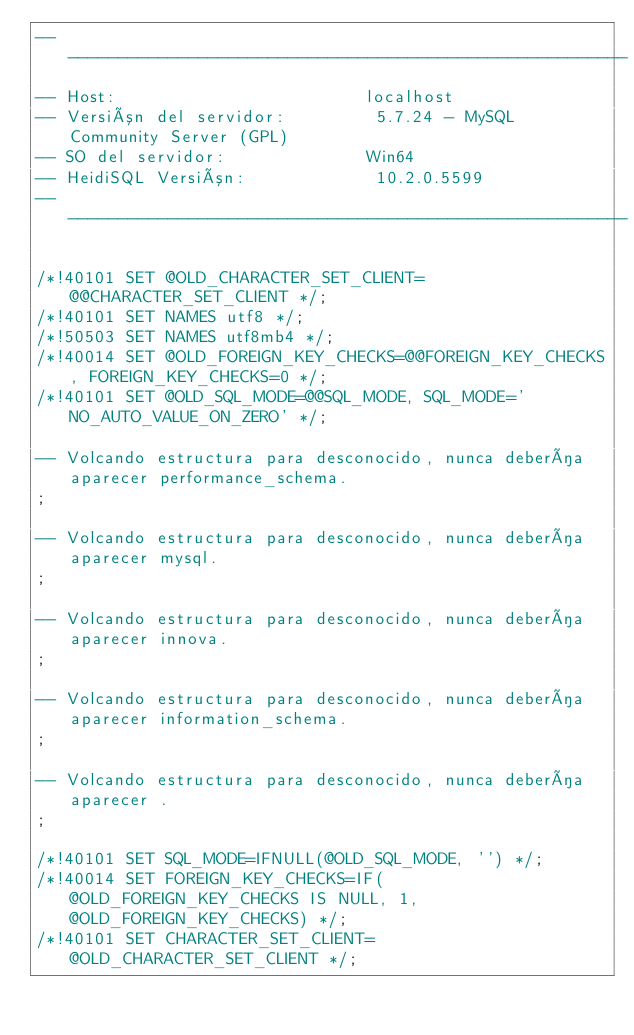Convert code to text. <code><loc_0><loc_0><loc_500><loc_500><_SQL_>-- --------------------------------------------------------
-- Host:                         localhost
-- Versión del servidor:         5.7.24 - MySQL Community Server (GPL)
-- SO del servidor:              Win64
-- HeidiSQL Versión:             10.2.0.5599
-- --------------------------------------------------------

/*!40101 SET @OLD_CHARACTER_SET_CLIENT=@@CHARACTER_SET_CLIENT */;
/*!40101 SET NAMES utf8 */;
/*!50503 SET NAMES utf8mb4 */;
/*!40014 SET @OLD_FOREIGN_KEY_CHECKS=@@FOREIGN_KEY_CHECKS, FOREIGN_KEY_CHECKS=0 */;
/*!40101 SET @OLD_SQL_MODE=@@SQL_MODE, SQL_MODE='NO_AUTO_VALUE_ON_ZERO' */;

-- Volcando estructura para desconocido, nunca debería aparecer performance_schema.
;

-- Volcando estructura para desconocido, nunca debería aparecer mysql.
;

-- Volcando estructura para desconocido, nunca debería aparecer innova.
;

-- Volcando estructura para desconocido, nunca debería aparecer information_schema.
;

-- Volcando estructura para desconocido, nunca debería aparecer .
;

/*!40101 SET SQL_MODE=IFNULL(@OLD_SQL_MODE, '') */;
/*!40014 SET FOREIGN_KEY_CHECKS=IF(@OLD_FOREIGN_KEY_CHECKS IS NULL, 1, @OLD_FOREIGN_KEY_CHECKS) */;
/*!40101 SET CHARACTER_SET_CLIENT=@OLD_CHARACTER_SET_CLIENT */;
</code> 